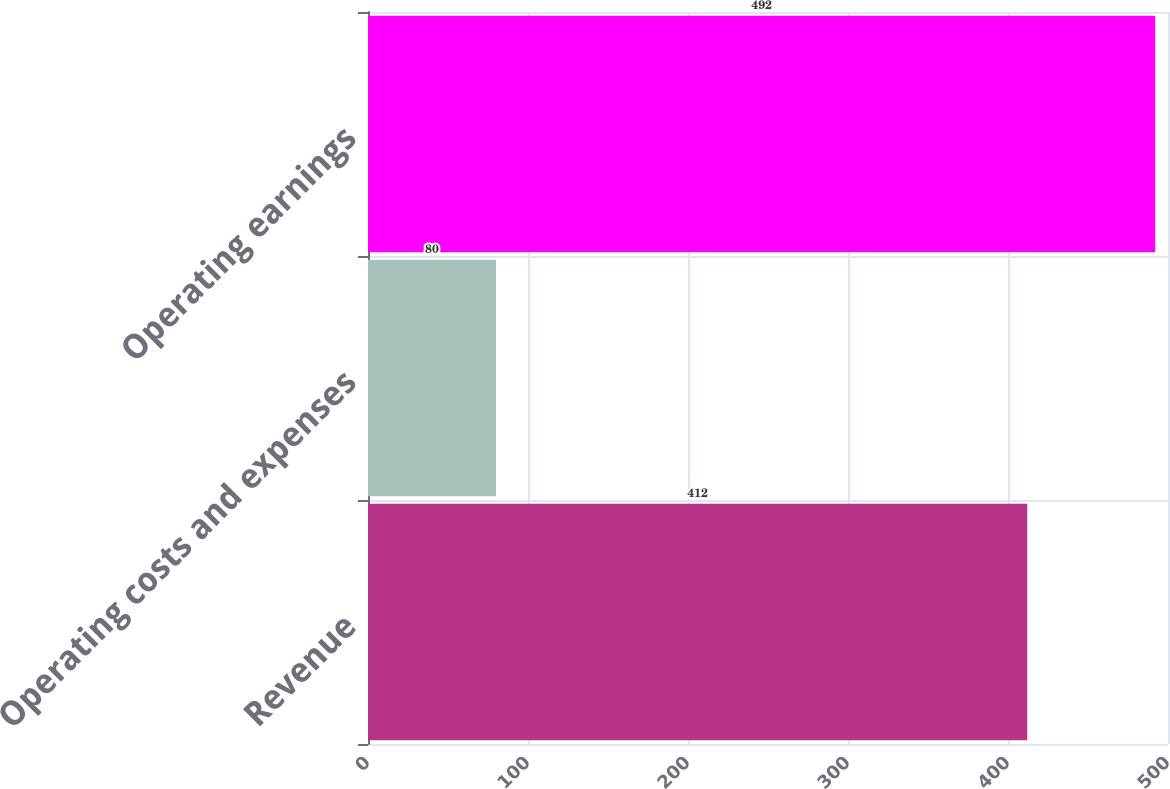<chart> <loc_0><loc_0><loc_500><loc_500><bar_chart><fcel>Revenue<fcel>Operating costs and expenses<fcel>Operating earnings<nl><fcel>412<fcel>80<fcel>492<nl></chart> 